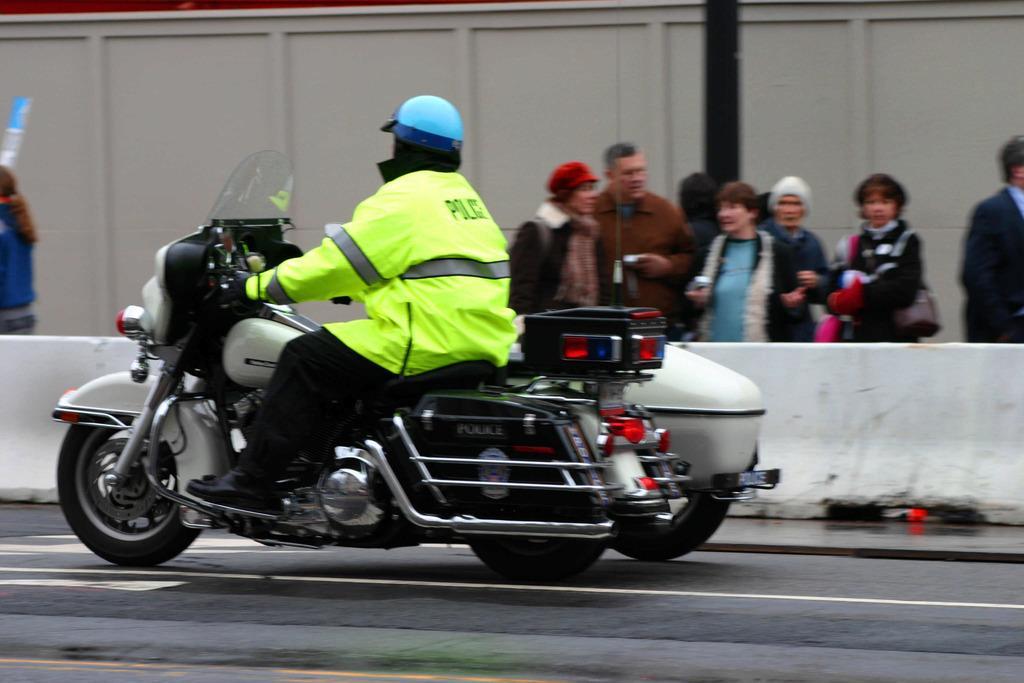How would you summarize this image in a sentence or two? There is a person on a vehicle in the foreground and there are people, it seems like a boundary, a wooden wall and a pole in the background area. 